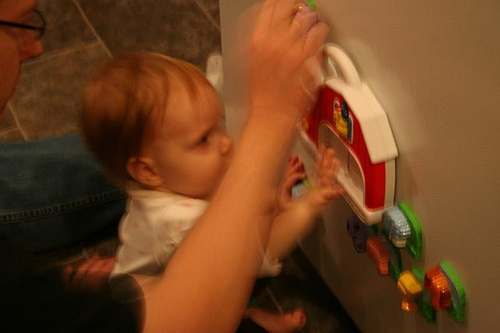Describe the objects in this image and their specific colors. I can see refrigerator in maroon, brown, and black tones, people in maroon, black, brown, and red tones, and people in maroon, brown, and black tones in this image. 